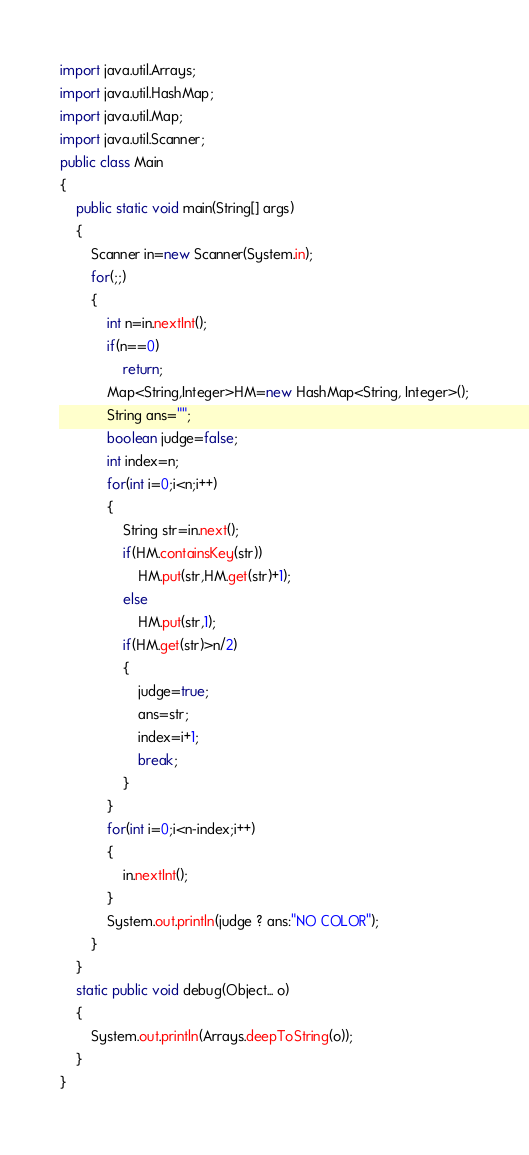Convert code to text. <code><loc_0><loc_0><loc_500><loc_500><_Java_>import java.util.Arrays;
import java.util.HashMap;
import java.util.Map;
import java.util.Scanner;
public class Main
{
	public static void main(String[] args) 
	{
		Scanner in=new Scanner(System.in);
		for(;;)
		{
			int n=in.nextInt();
			if(n==0)
				return;
			Map<String,Integer>HM=new HashMap<String, Integer>();
			String ans="";
			boolean judge=false;
			int index=n;
			for(int i=0;i<n;i++)
			{
				String str=in.next();
				if(HM.containsKey(str))
					HM.put(str,HM.get(str)+1);
				else
					HM.put(str,1);
				if(HM.get(str)>n/2)
				{
					judge=true;
					ans=str;
					index=i+1;
					break;
				}
			}
			for(int i=0;i<n-index;i++)
			{
				in.nextInt();
			}
			System.out.println(judge ? ans:"NO COLOR");
		}
	}
	static public void debug(Object... o)
	{
		System.out.println(Arrays.deepToString(o));
	}
}</code> 